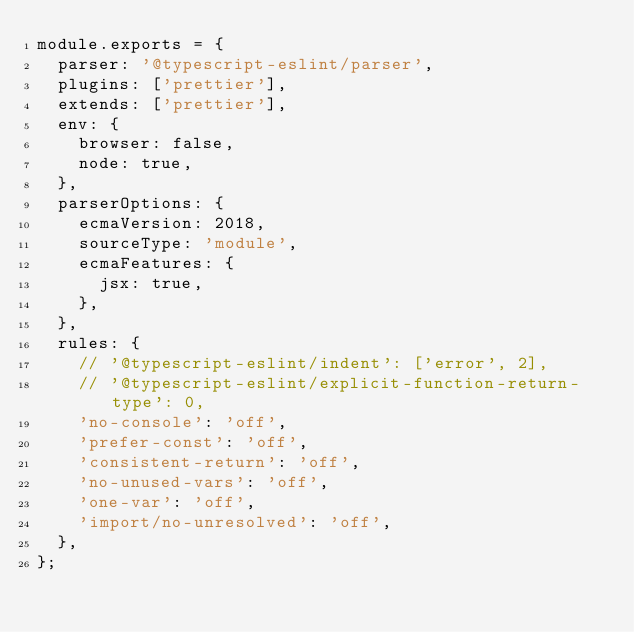Convert code to text. <code><loc_0><loc_0><loc_500><loc_500><_JavaScript_>module.exports = {
  parser: '@typescript-eslint/parser',
  plugins: ['prettier'],
  extends: ['prettier'],
  env: {
    browser: false,
    node: true,
  },
  parserOptions: {
    ecmaVersion: 2018,
    sourceType: 'module',
    ecmaFeatures: {
      jsx: true,
    },
  },
  rules: {
    // '@typescript-eslint/indent': ['error', 2],
    // '@typescript-eslint/explicit-function-return-type': 0,
    'no-console': 'off',
    'prefer-const': 'off',
    'consistent-return': 'off',
    'no-unused-vars': 'off',
    'one-var': 'off',
    'import/no-unresolved': 'off',
  },
};
</code> 